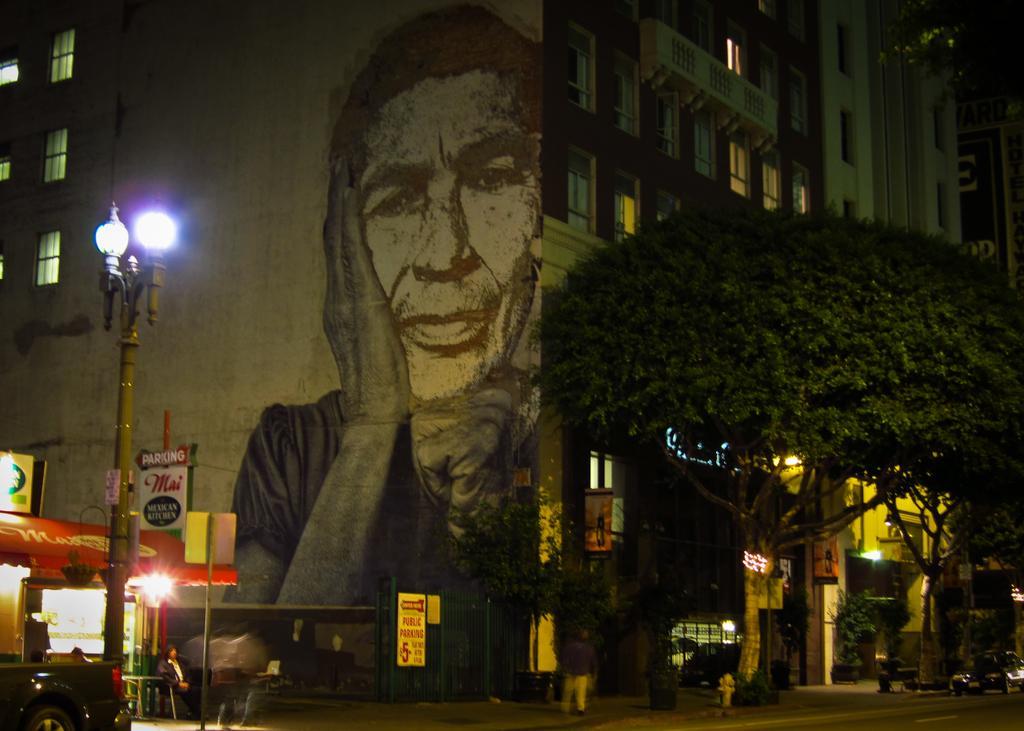Can you describe this image briefly? In this picture we can see building. There is a picture of a man which is on the banner. On the bottom left corner there is a man who is wearing jacket, jeans and shoe. He is standing near to the shop. Here we can see the black color car which is near to the street light. On the bottom we can see two persons walking on the road. On the bottom right corner we can see vehicles which is near to the trees. Here we can see posters, board and plant. 